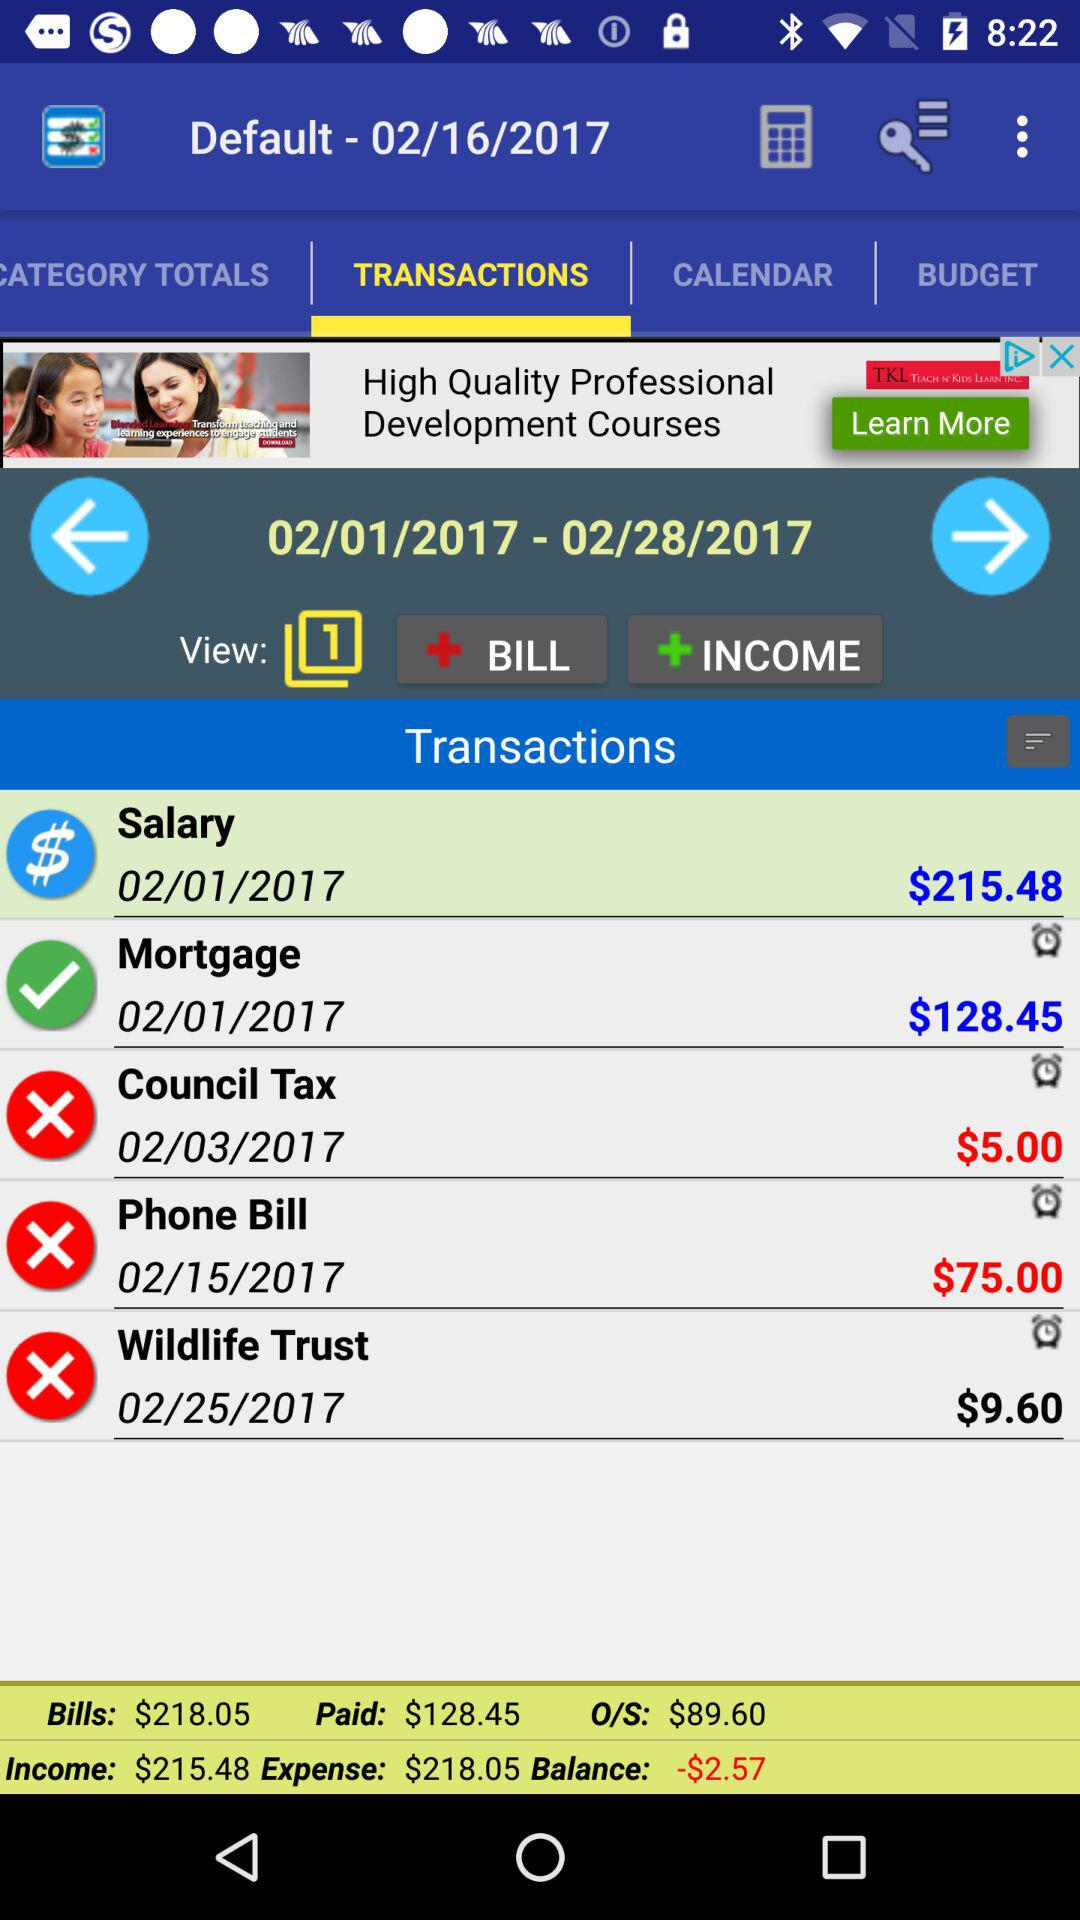Which tab is currently selected? The currently selected tab is "TRANSACTIONS". 